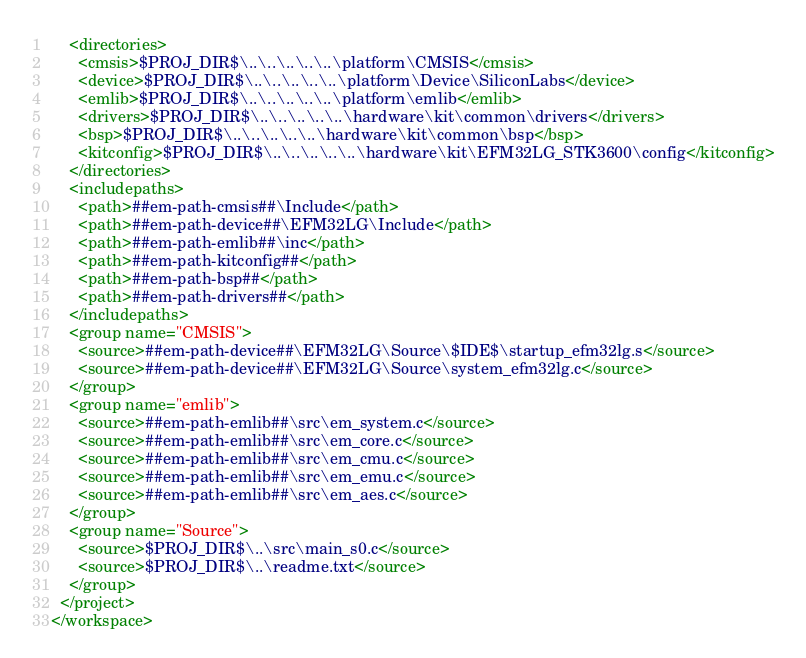Convert code to text. <code><loc_0><loc_0><loc_500><loc_500><_XML_>    <directories>
      <cmsis>$PROJ_DIR$\..\..\..\..\..\platform\CMSIS</cmsis>
      <device>$PROJ_DIR$\..\..\..\..\..\platform\Device\SiliconLabs</device>
      <emlib>$PROJ_DIR$\..\..\..\..\..\platform\emlib</emlib>
      <drivers>$PROJ_DIR$\..\..\..\..\..\hardware\kit\common\drivers</drivers>
      <bsp>$PROJ_DIR$\..\..\..\..\..\hardware\kit\common\bsp</bsp>
      <kitconfig>$PROJ_DIR$\..\..\..\..\..\hardware\kit\EFM32LG_STK3600\config</kitconfig>
    </directories>
    <includepaths>
      <path>##em-path-cmsis##\Include</path>
      <path>##em-path-device##\EFM32LG\Include</path>
      <path>##em-path-emlib##\inc</path>
      <path>##em-path-kitconfig##</path>
      <path>##em-path-bsp##</path>
      <path>##em-path-drivers##</path>
    </includepaths>
    <group name="CMSIS">
      <source>##em-path-device##\EFM32LG\Source\$IDE$\startup_efm32lg.s</source>
      <source>##em-path-device##\EFM32LG\Source\system_efm32lg.c</source>
    </group>
    <group name="emlib">
      <source>##em-path-emlib##\src\em_system.c</source>
      <source>##em-path-emlib##\src\em_core.c</source>
      <source>##em-path-emlib##\src\em_cmu.c</source>
      <source>##em-path-emlib##\src\em_emu.c</source>
      <source>##em-path-emlib##\src\em_aes.c</source>
    </group>
    <group name="Source">
      <source>$PROJ_DIR$\..\src\main_s0.c</source>
      <source>$PROJ_DIR$\..\readme.txt</source>
    </group>
  </project>
</workspace>
</code> 